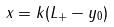<formula> <loc_0><loc_0><loc_500><loc_500>x = k ( L _ { + } - y _ { 0 } )</formula> 